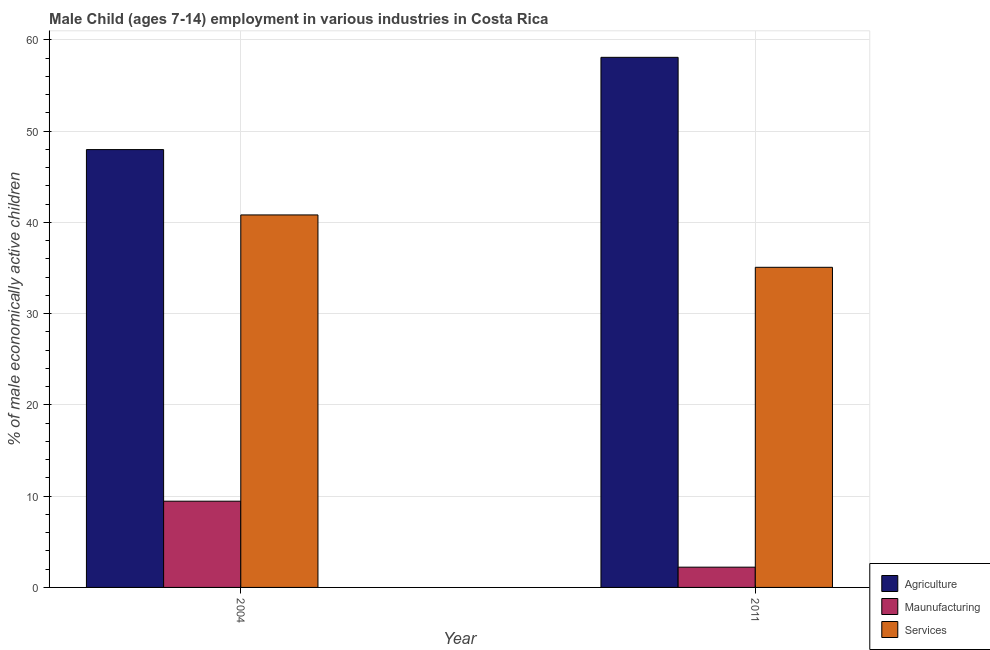How many different coloured bars are there?
Your answer should be very brief. 3. Are the number of bars per tick equal to the number of legend labels?
Offer a terse response. Yes. In how many cases, is the number of bars for a given year not equal to the number of legend labels?
Your response must be concise. 0. What is the percentage of economically active children in services in 2004?
Give a very brief answer. 40.82. Across all years, what is the maximum percentage of economically active children in manufacturing?
Ensure brevity in your answer.  9.45. Across all years, what is the minimum percentage of economically active children in manufacturing?
Your response must be concise. 2.22. In which year was the percentage of economically active children in agriculture minimum?
Ensure brevity in your answer.  2004. What is the total percentage of economically active children in manufacturing in the graph?
Make the answer very short. 11.67. What is the difference between the percentage of economically active children in agriculture in 2004 and that in 2011?
Offer a terse response. -10.11. What is the difference between the percentage of economically active children in services in 2011 and the percentage of economically active children in manufacturing in 2004?
Your answer should be compact. -5.74. What is the average percentage of economically active children in agriculture per year?
Offer a very short reply. 53.03. In the year 2004, what is the difference between the percentage of economically active children in services and percentage of economically active children in agriculture?
Provide a short and direct response. 0. In how many years, is the percentage of economically active children in services greater than 50 %?
Offer a terse response. 0. What is the ratio of the percentage of economically active children in agriculture in 2004 to that in 2011?
Your answer should be compact. 0.83. In how many years, is the percentage of economically active children in agriculture greater than the average percentage of economically active children in agriculture taken over all years?
Offer a very short reply. 1. What does the 1st bar from the left in 2011 represents?
Ensure brevity in your answer.  Agriculture. What does the 3rd bar from the right in 2004 represents?
Ensure brevity in your answer.  Agriculture. Is it the case that in every year, the sum of the percentage of economically active children in agriculture and percentage of economically active children in manufacturing is greater than the percentage of economically active children in services?
Your answer should be very brief. Yes. How many bars are there?
Make the answer very short. 6. Are all the bars in the graph horizontal?
Your response must be concise. No. How many years are there in the graph?
Ensure brevity in your answer.  2. Does the graph contain grids?
Make the answer very short. Yes. How are the legend labels stacked?
Give a very brief answer. Vertical. What is the title of the graph?
Your response must be concise. Male Child (ages 7-14) employment in various industries in Costa Rica. Does "Interest" appear as one of the legend labels in the graph?
Your response must be concise. No. What is the label or title of the Y-axis?
Give a very brief answer. % of male economically active children. What is the % of male economically active children of Agriculture in 2004?
Give a very brief answer. 47.98. What is the % of male economically active children in Maunufacturing in 2004?
Offer a terse response. 9.45. What is the % of male economically active children in Services in 2004?
Offer a terse response. 40.82. What is the % of male economically active children in Agriculture in 2011?
Your response must be concise. 58.09. What is the % of male economically active children in Maunufacturing in 2011?
Keep it short and to the point. 2.22. What is the % of male economically active children of Services in 2011?
Give a very brief answer. 35.08. Across all years, what is the maximum % of male economically active children in Agriculture?
Keep it short and to the point. 58.09. Across all years, what is the maximum % of male economically active children in Maunufacturing?
Provide a succinct answer. 9.45. Across all years, what is the maximum % of male economically active children in Services?
Offer a very short reply. 40.82. Across all years, what is the minimum % of male economically active children of Agriculture?
Your response must be concise. 47.98. Across all years, what is the minimum % of male economically active children in Maunufacturing?
Your response must be concise. 2.22. Across all years, what is the minimum % of male economically active children of Services?
Provide a short and direct response. 35.08. What is the total % of male economically active children of Agriculture in the graph?
Give a very brief answer. 106.07. What is the total % of male economically active children of Maunufacturing in the graph?
Ensure brevity in your answer.  11.67. What is the total % of male economically active children in Services in the graph?
Provide a short and direct response. 75.9. What is the difference between the % of male economically active children of Agriculture in 2004 and that in 2011?
Provide a short and direct response. -10.11. What is the difference between the % of male economically active children of Maunufacturing in 2004 and that in 2011?
Make the answer very short. 7.23. What is the difference between the % of male economically active children in Services in 2004 and that in 2011?
Provide a short and direct response. 5.74. What is the difference between the % of male economically active children of Agriculture in 2004 and the % of male economically active children of Maunufacturing in 2011?
Make the answer very short. 45.76. What is the difference between the % of male economically active children in Maunufacturing in 2004 and the % of male economically active children in Services in 2011?
Your answer should be compact. -25.63. What is the average % of male economically active children of Agriculture per year?
Offer a terse response. 53.03. What is the average % of male economically active children of Maunufacturing per year?
Keep it short and to the point. 5.83. What is the average % of male economically active children in Services per year?
Offer a terse response. 37.95. In the year 2004, what is the difference between the % of male economically active children in Agriculture and % of male economically active children in Maunufacturing?
Keep it short and to the point. 38.53. In the year 2004, what is the difference between the % of male economically active children in Agriculture and % of male economically active children in Services?
Provide a short and direct response. 7.16. In the year 2004, what is the difference between the % of male economically active children of Maunufacturing and % of male economically active children of Services?
Provide a short and direct response. -31.37. In the year 2011, what is the difference between the % of male economically active children in Agriculture and % of male economically active children in Maunufacturing?
Your answer should be very brief. 55.87. In the year 2011, what is the difference between the % of male economically active children of Agriculture and % of male economically active children of Services?
Your answer should be very brief. 23.01. In the year 2011, what is the difference between the % of male economically active children of Maunufacturing and % of male economically active children of Services?
Keep it short and to the point. -32.86. What is the ratio of the % of male economically active children of Agriculture in 2004 to that in 2011?
Your response must be concise. 0.83. What is the ratio of the % of male economically active children of Maunufacturing in 2004 to that in 2011?
Your answer should be compact. 4.26. What is the ratio of the % of male economically active children of Services in 2004 to that in 2011?
Your answer should be compact. 1.16. What is the difference between the highest and the second highest % of male economically active children in Agriculture?
Provide a succinct answer. 10.11. What is the difference between the highest and the second highest % of male economically active children in Maunufacturing?
Ensure brevity in your answer.  7.23. What is the difference between the highest and the second highest % of male economically active children in Services?
Offer a terse response. 5.74. What is the difference between the highest and the lowest % of male economically active children of Agriculture?
Give a very brief answer. 10.11. What is the difference between the highest and the lowest % of male economically active children in Maunufacturing?
Offer a terse response. 7.23. What is the difference between the highest and the lowest % of male economically active children in Services?
Your response must be concise. 5.74. 